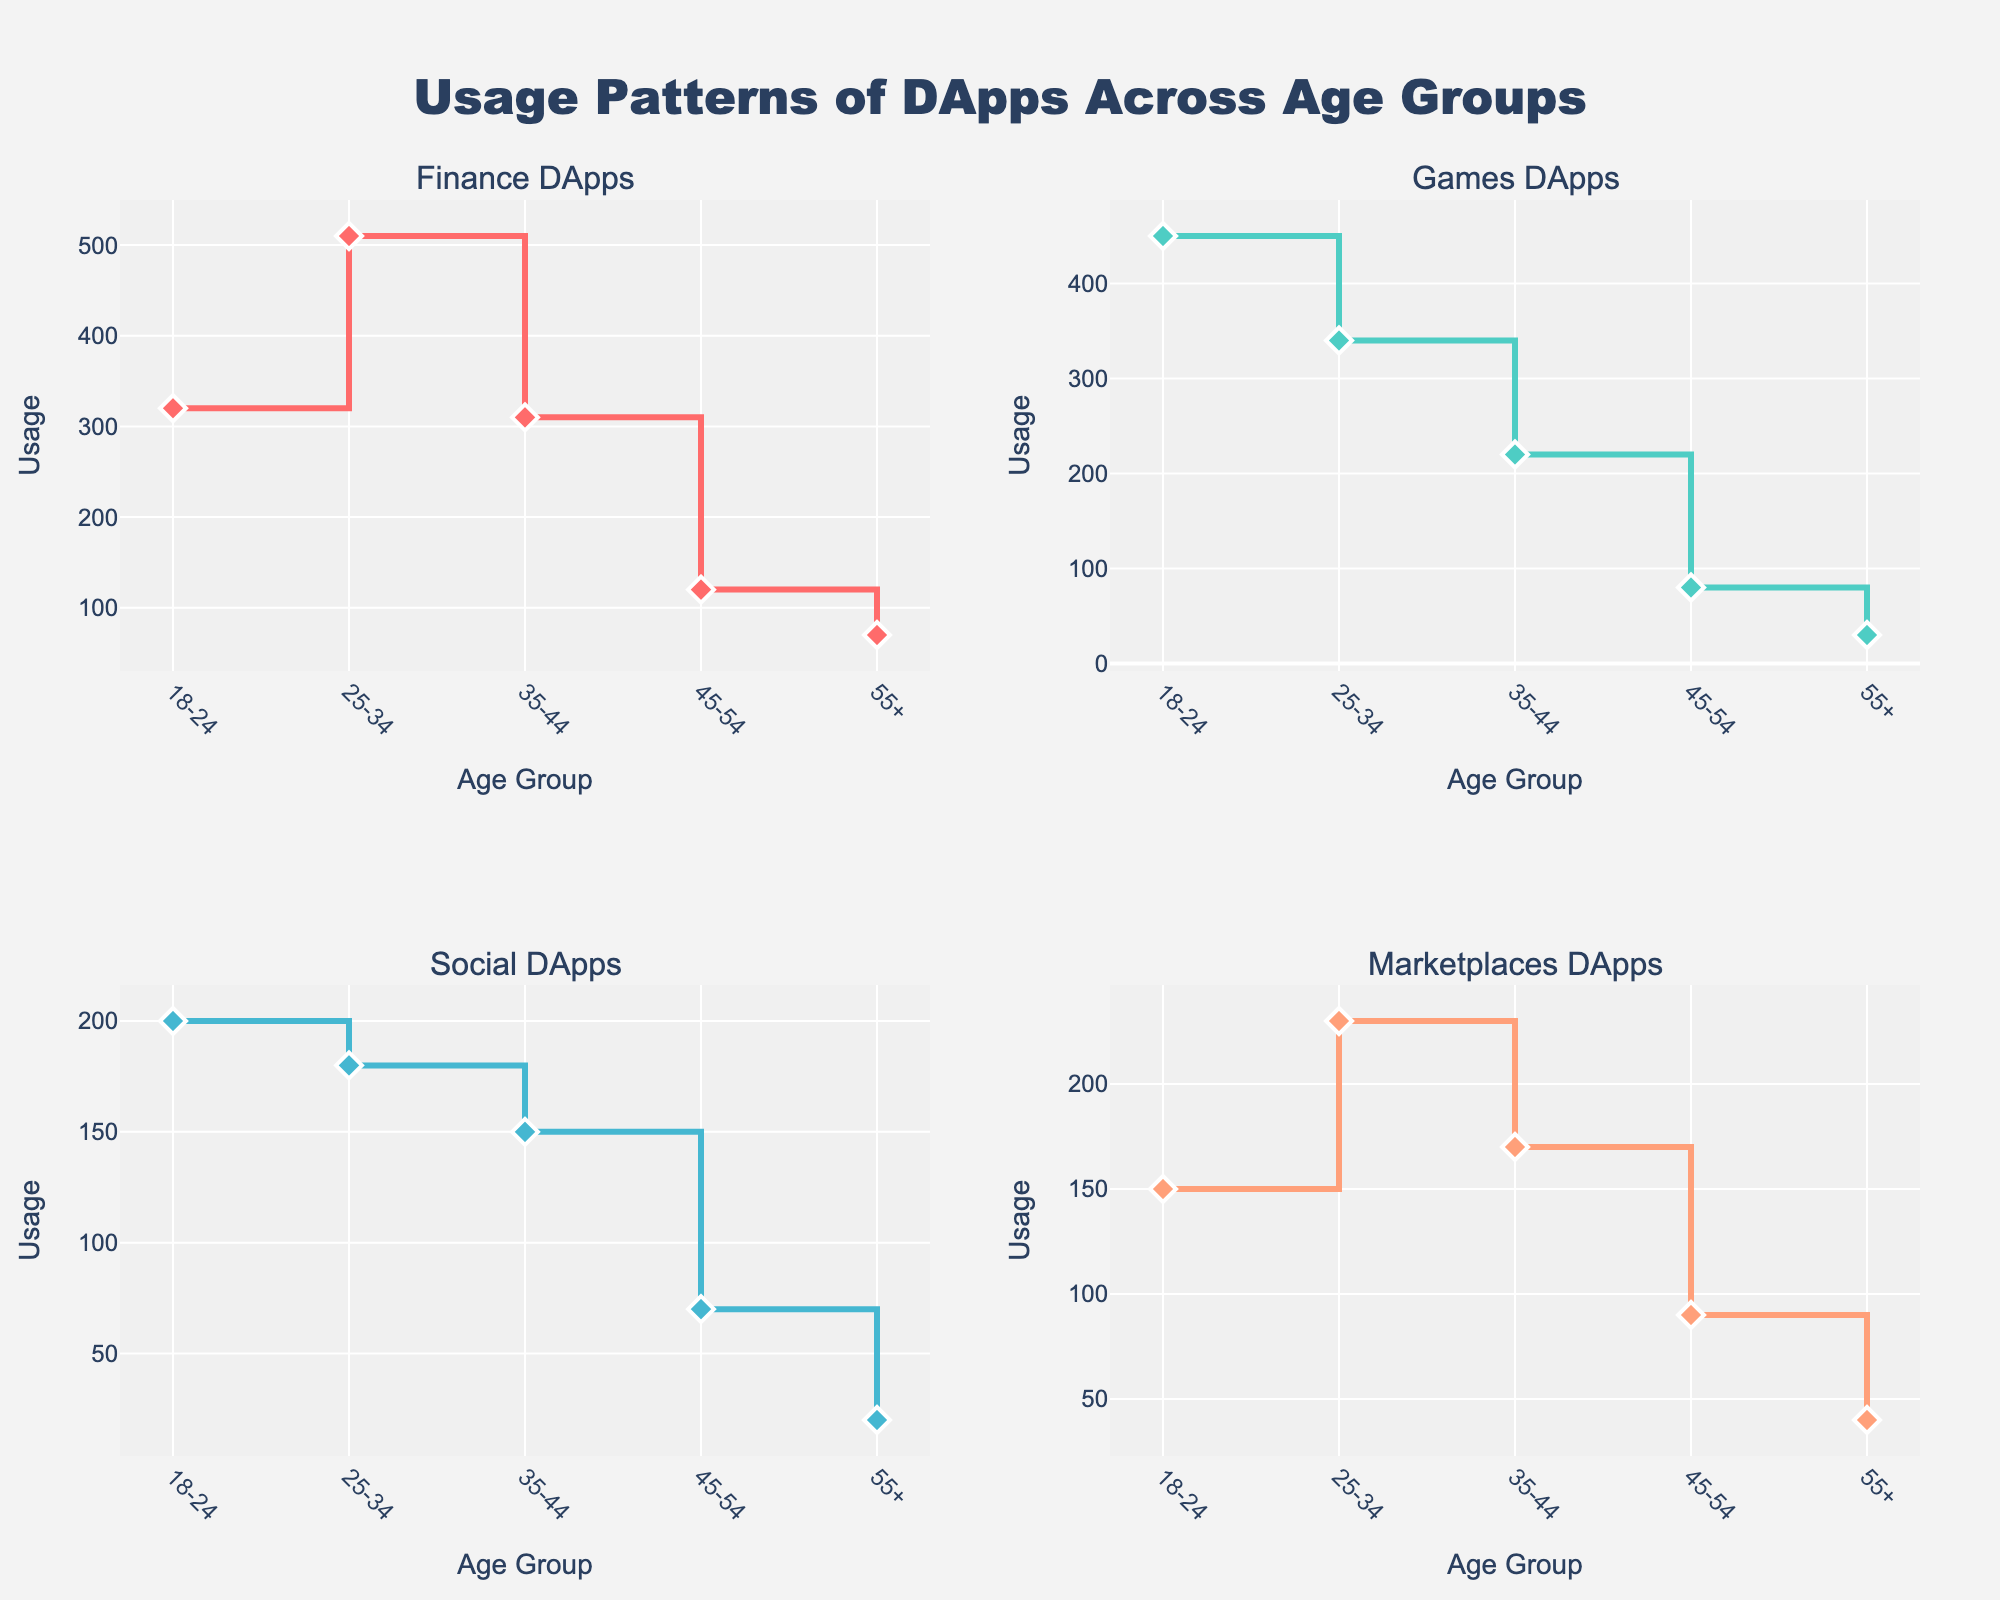what is the title of the figure? The title of the figure is displayed at the top center of the figure. By reading this section, we can determine the title.
Answer: Usage Patterns of DApps Across Age Groups how many age groups are shown in each subplot? Observe the x-axis in any of the subplots. The x-axis labels represent the age groups, and you can count them.
Answer: 5 what color is used for the Finance DApps line? Look at the line and markers' colors in the subplot titled 'Finance DApps'. The visual clue indicates a particular color.
Answer: Red which age group has the highest usage in Games DApps? Compare the heights of the data points in the 'Games DApps' subplot. The highest point indicates the age group with the highest usage.
Answer: 18-24 what is the total usage of Marketplaces DApps across all age groups? Sum the y-values in the 'Marketplaces DApps' subplot. Specifically, the usage values are 150, 230, 170, 90, and 40. Adding them gives the total. 150 + 230 + 170 + 90 + 40 = 680
Answer: 680 which age group sees a decline in usage for all types of DApps as compared to the previous age group? Examine all the subplots and observe each age group's usage pattern across all DApp types. Look for the age group where every DApp type shows a decrease compared to the preceding age group.
Answer: 45-54 what is the difference in usage of Finance DApps between the age groups 25-34 and 55+? Identify the y-values for the age groups 25-34 and 55+ in the 'Finance DApps' subplot. The difference is calculated as 510 - 70.
Answer: 440 in which age group is the usage of Social DApps at its lowest, and what is this value? Check the y-values for 'Social DApps'. The lowest value is the smallest among them, and the corresponding age group gives you the answer.
Answer: 55+, 20 how does the usage pattern of Marketplaces DApps change across age groups? Describe the trend of the data points in the 'Marketplaces DApps' subplot. Note if the usage increases, decreases, or fluctuates as you move through age groups.
Answer: Mixed; increases then decreases 